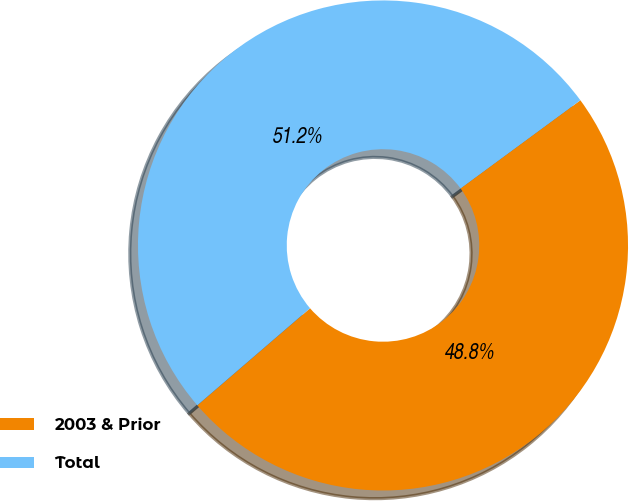<chart> <loc_0><loc_0><loc_500><loc_500><pie_chart><fcel>2003 & Prior<fcel>Total<nl><fcel>48.78%<fcel>51.22%<nl></chart> 